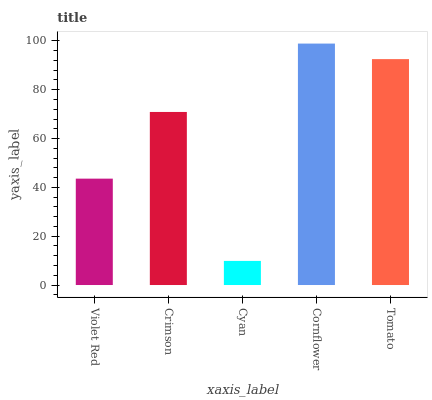Is Cyan the minimum?
Answer yes or no. Yes. Is Cornflower the maximum?
Answer yes or no. Yes. Is Crimson the minimum?
Answer yes or no. No. Is Crimson the maximum?
Answer yes or no. No. Is Crimson greater than Violet Red?
Answer yes or no. Yes. Is Violet Red less than Crimson?
Answer yes or no. Yes. Is Violet Red greater than Crimson?
Answer yes or no. No. Is Crimson less than Violet Red?
Answer yes or no. No. Is Crimson the high median?
Answer yes or no. Yes. Is Crimson the low median?
Answer yes or no. Yes. Is Tomato the high median?
Answer yes or no. No. Is Tomato the low median?
Answer yes or no. No. 